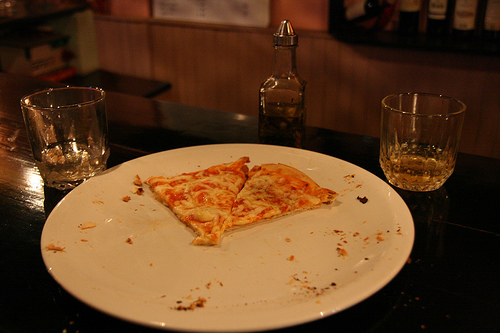Is the pizza on the plate yellow and small? Yes, the pizza slices on the plate are relatively small and have a yellowish tint due to the cheese melting. 